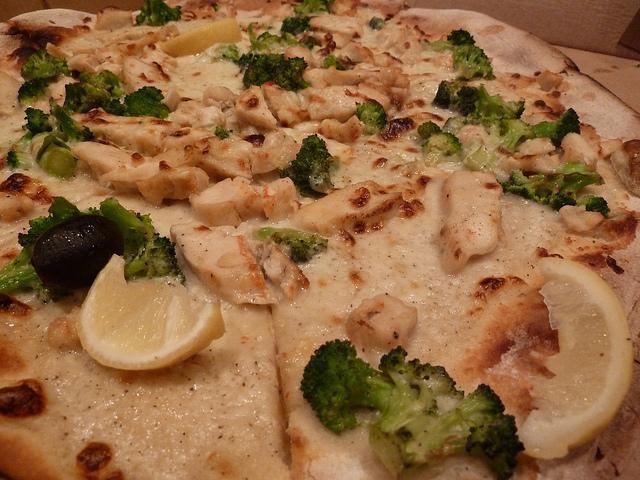How many broccolis are there?
Give a very brief answer. 8. 